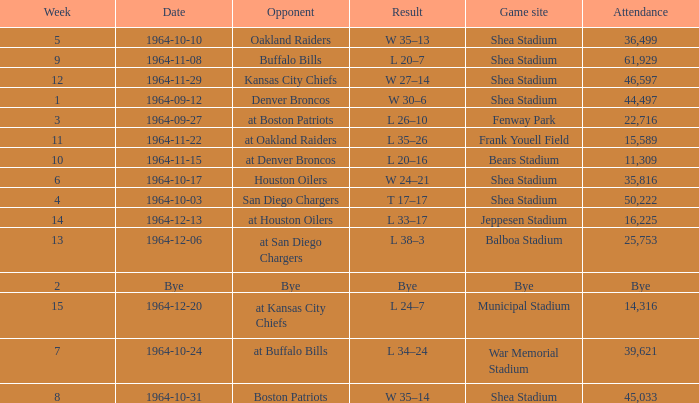Where did the Jet's play with an attendance of 11,309? Bears Stadium. 